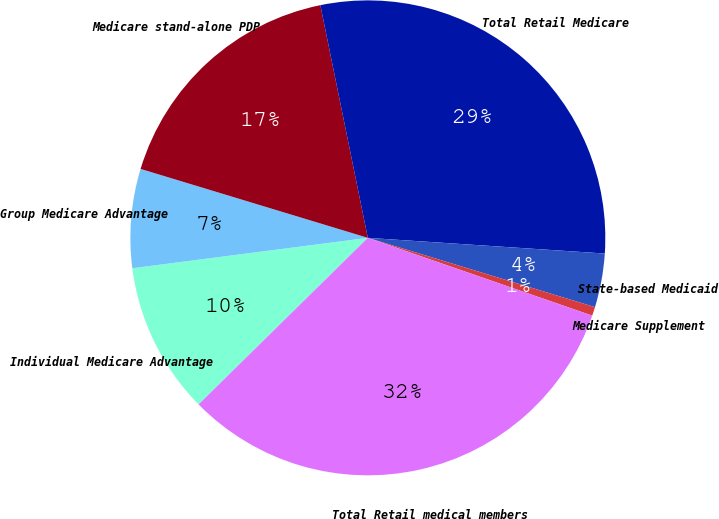Convert chart to OTSL. <chart><loc_0><loc_0><loc_500><loc_500><pie_chart><fcel>Individual Medicare Advantage<fcel>Group Medicare Advantage<fcel>Medicare stand-alone PDP<fcel>Total Retail Medicare<fcel>State-based Medicaid<fcel>Medicare Supplement<fcel>Total Retail medical members<nl><fcel>10.33%<fcel>6.73%<fcel>17.11%<fcel>29.26%<fcel>3.66%<fcel>0.6%<fcel>32.32%<nl></chart> 